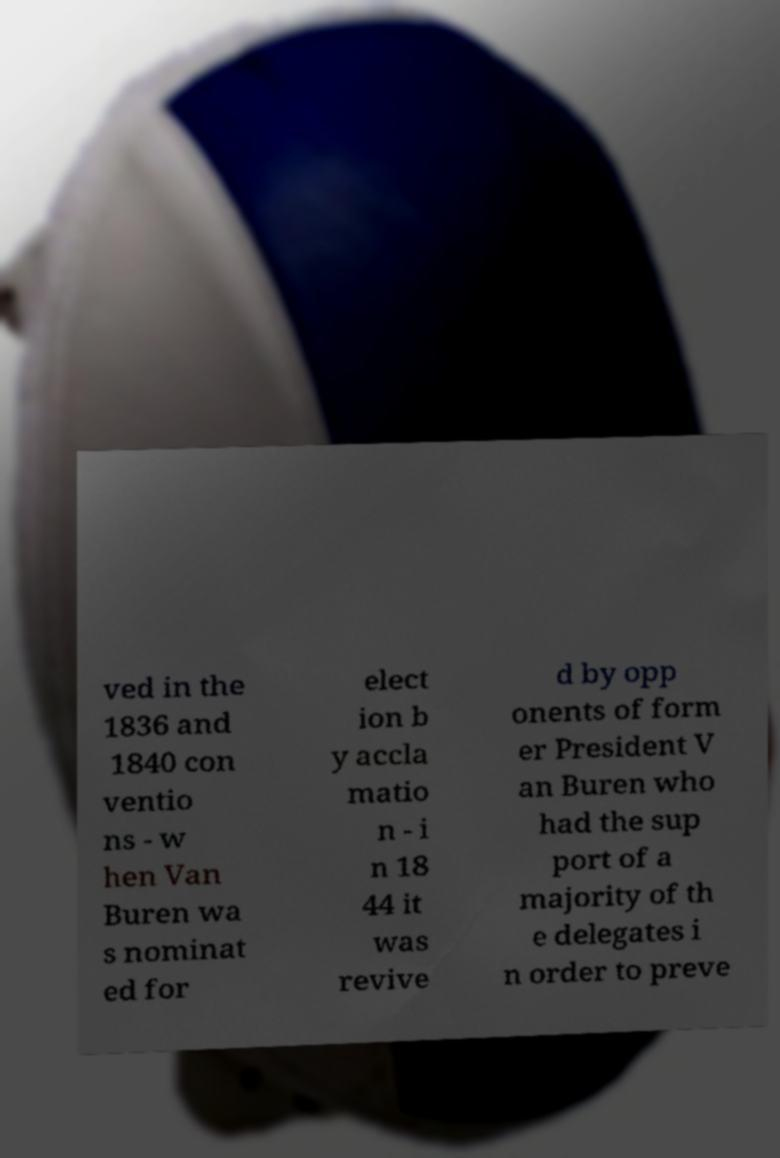Could you assist in decoding the text presented in this image and type it out clearly? ved in the 1836 and 1840 con ventio ns - w hen Van Buren wa s nominat ed for elect ion b y accla matio n - i n 18 44 it was revive d by opp onents of form er President V an Buren who had the sup port of a majority of th e delegates i n order to preve 